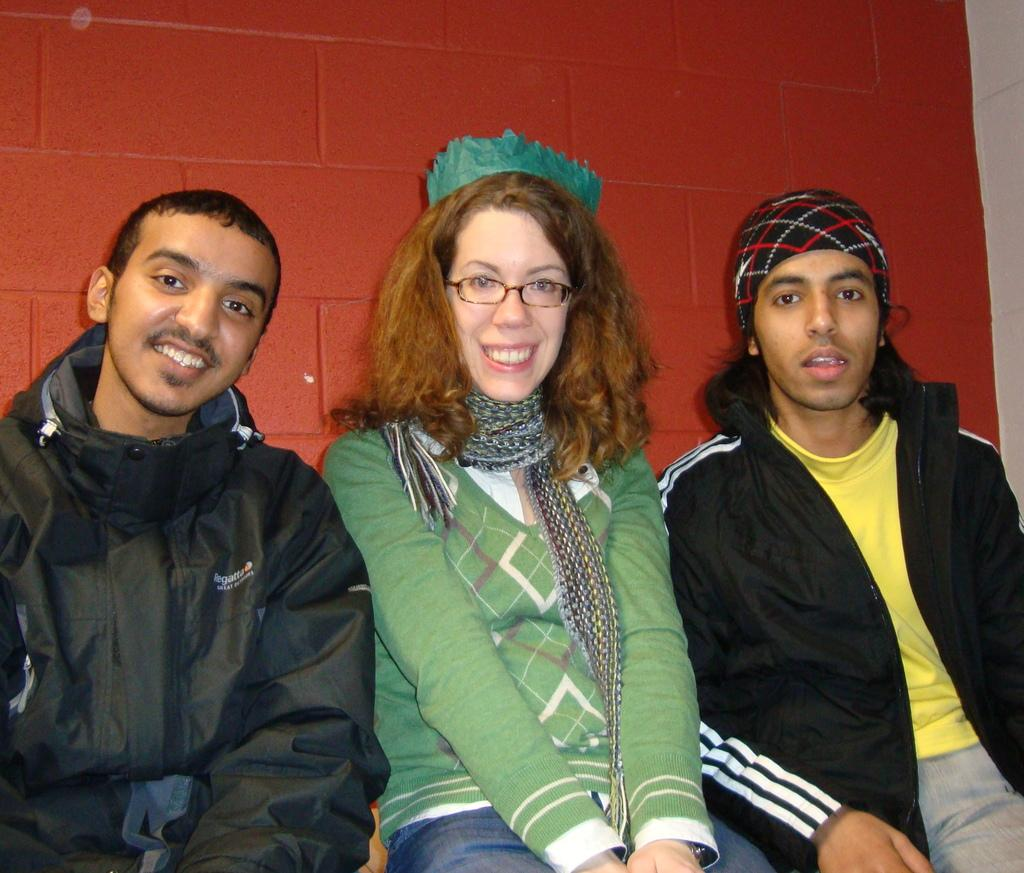How many people are in the image? There are three people in the image. What are the people doing in the image? The people are sitting. What can be seen in the background of the image? There is a red color wall in the background of the image. What type of thought can be seen floating above the people's heads in the image? There are no thoughts visible in the image; it only shows three people sitting. 